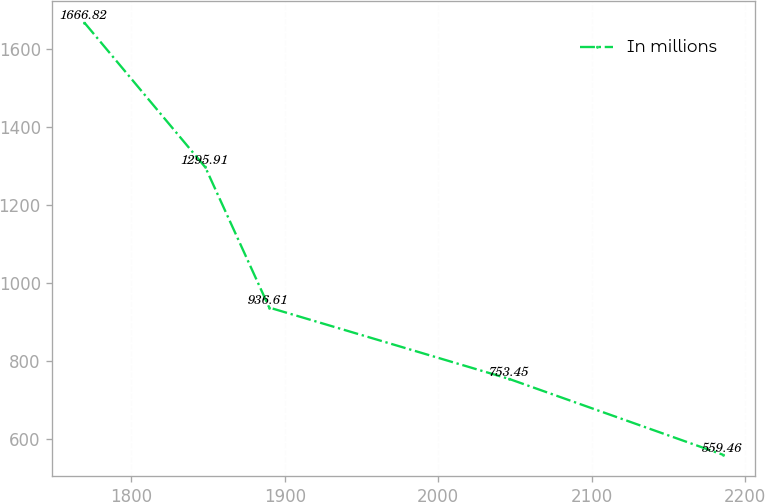Convert chart. <chart><loc_0><loc_0><loc_500><loc_500><line_chart><ecel><fcel>In millions<nl><fcel>1769.35<fcel>1666.82<nl><fcel>1848.21<fcel>1295.91<nl><fcel>1889.83<fcel>936.61<nl><fcel>2046.4<fcel>753.45<nl><fcel>2185.52<fcel>559.46<nl></chart> 